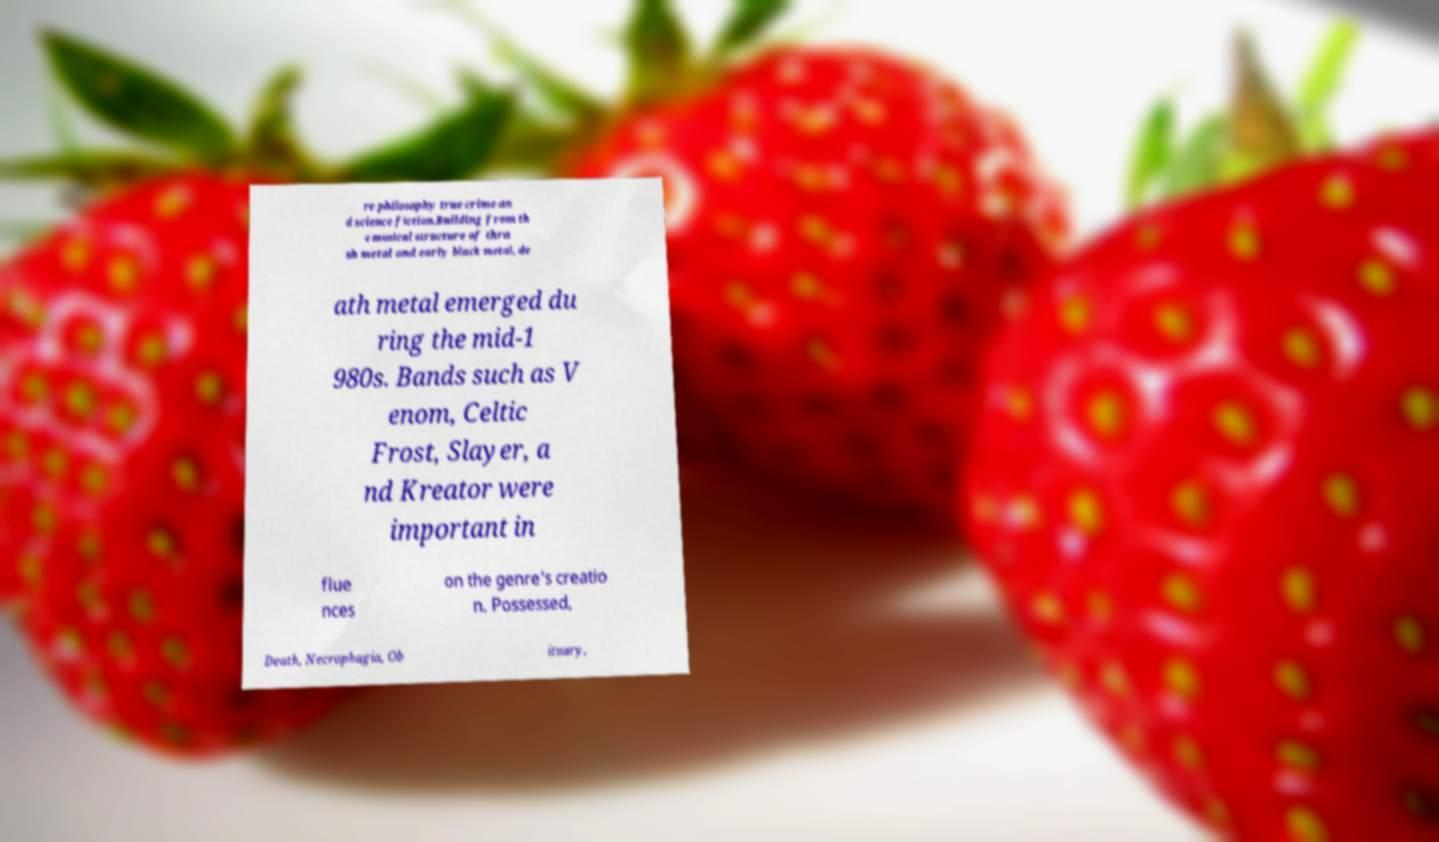For documentation purposes, I need the text within this image transcribed. Could you provide that? re philosophy true crime an d science fiction.Building from th e musical structure of thra sh metal and early black metal, de ath metal emerged du ring the mid-1 980s. Bands such as V enom, Celtic Frost, Slayer, a nd Kreator were important in flue nces on the genre's creatio n. Possessed, Death, Necrophagia, Ob ituary, 